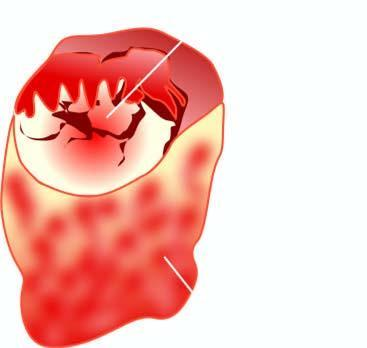does the nodule show grossly visible papillary pattern?
Answer the question using a single word or phrase. Yes 